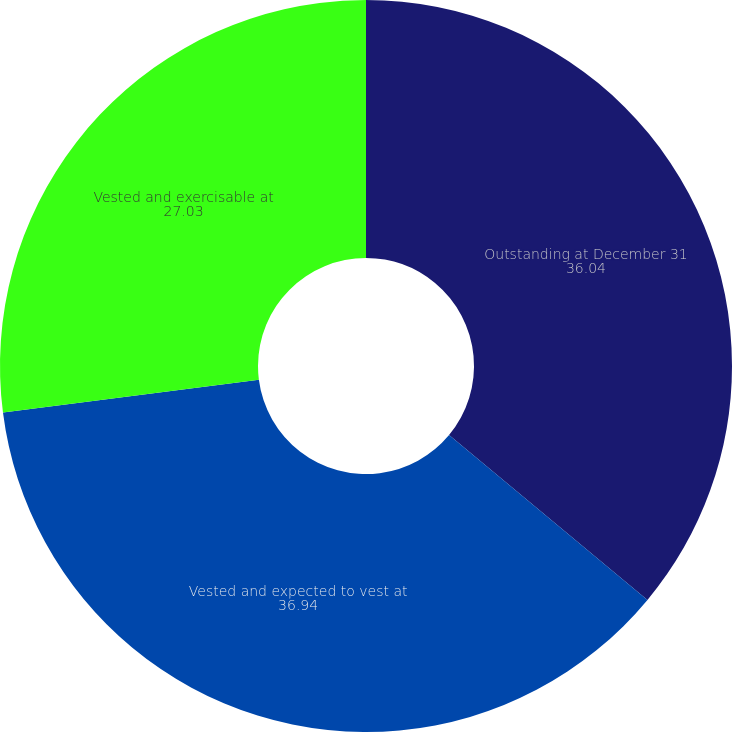Convert chart. <chart><loc_0><loc_0><loc_500><loc_500><pie_chart><fcel>Outstanding at December 31<fcel>Vested and expected to vest at<fcel>Vested and exercisable at<nl><fcel>36.04%<fcel>36.94%<fcel>27.03%<nl></chart> 